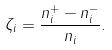<formula> <loc_0><loc_0><loc_500><loc_500>\zeta _ { i } = \frac { n _ { i } ^ { + } - n _ { i } ^ { - } } { n _ { i } } .</formula> 